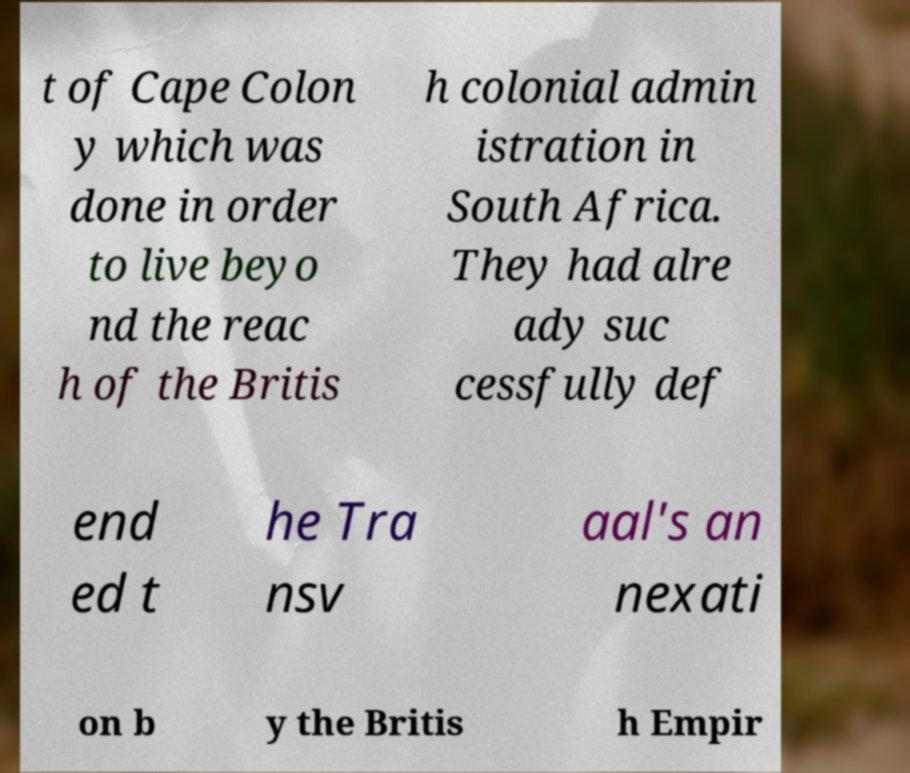Can you accurately transcribe the text from the provided image for me? t of Cape Colon y which was done in order to live beyo nd the reac h of the Britis h colonial admin istration in South Africa. They had alre ady suc cessfully def end ed t he Tra nsv aal's an nexati on b y the Britis h Empir 